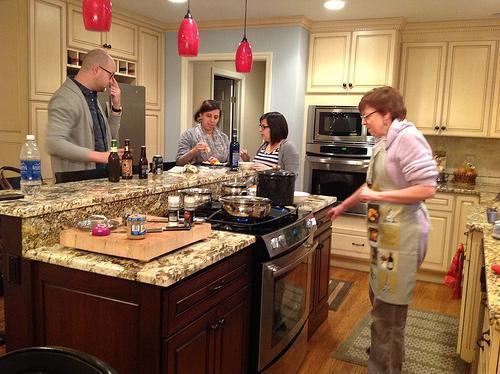How many people are in this room?
Give a very brief answer. 4. How many people are wearing glasses?
Give a very brief answer. 3. How many people are wearing an apron?
Give a very brief answer. 1. How many bottles are on the counter top?
Give a very brief answer. 5. How many ovens are visible?
Give a very brief answer. 2. 